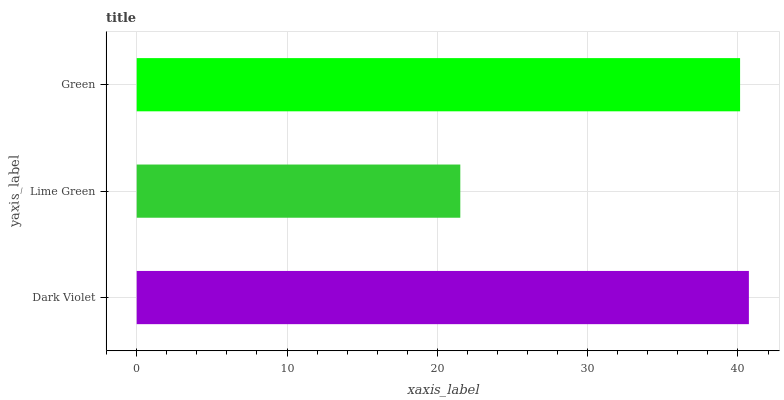Is Lime Green the minimum?
Answer yes or no. Yes. Is Dark Violet the maximum?
Answer yes or no. Yes. Is Green the minimum?
Answer yes or no. No. Is Green the maximum?
Answer yes or no. No. Is Green greater than Lime Green?
Answer yes or no. Yes. Is Lime Green less than Green?
Answer yes or no. Yes. Is Lime Green greater than Green?
Answer yes or no. No. Is Green less than Lime Green?
Answer yes or no. No. Is Green the high median?
Answer yes or no. Yes. Is Green the low median?
Answer yes or no. Yes. Is Dark Violet the high median?
Answer yes or no. No. Is Lime Green the low median?
Answer yes or no. No. 